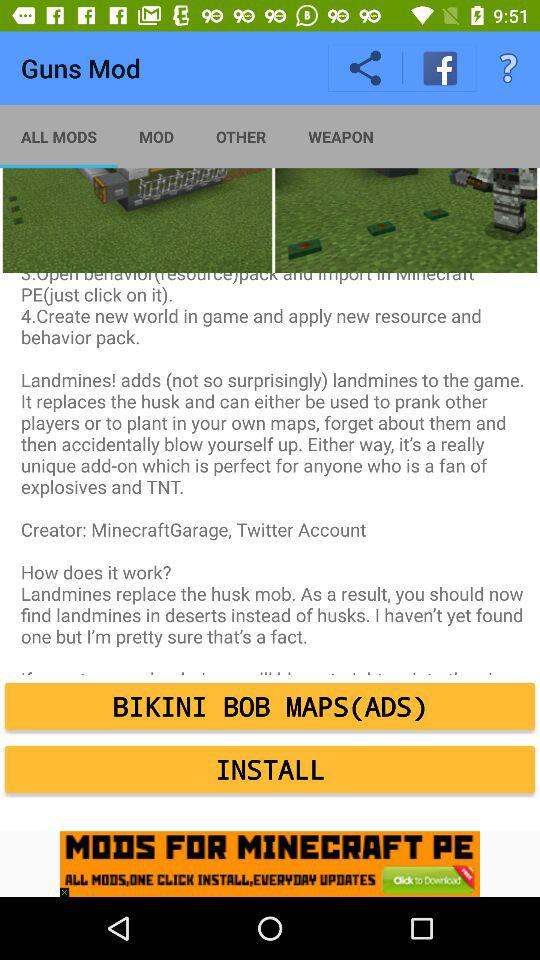How many steps are in the instructions?
Answer the question using a single word or phrase. 4 